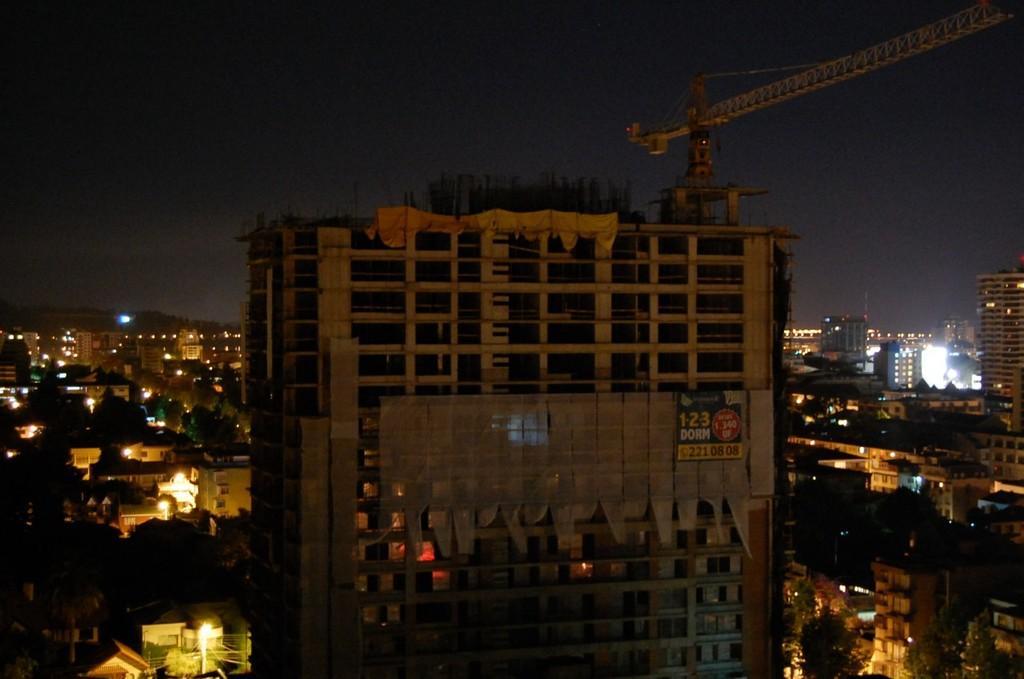Could you give a brief overview of what you see in this image? There is a building. On the building there is a tower crane and a banner. Also there are many buildings, trees and lights. In the background there is sky. 